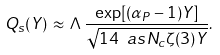Convert formula to latex. <formula><loc_0><loc_0><loc_500><loc_500>Q _ { s } ( Y ) \, \approx \, \Lambda \, \frac { \exp [ ( \alpha _ { P } - 1 ) Y ] } { \sqrt { 1 4 \ a s N _ { c } \zeta ( 3 ) Y } } .</formula> 